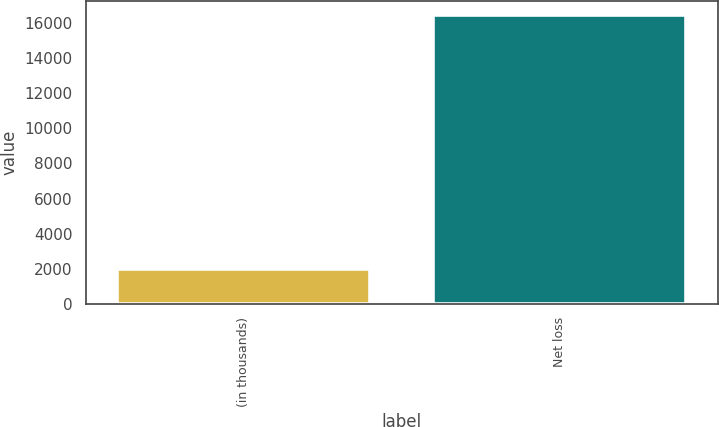Convert chart to OTSL. <chart><loc_0><loc_0><loc_500><loc_500><bar_chart><fcel>(in thousands)<fcel>Net loss<nl><fcel>2007<fcel>16425<nl></chart> 